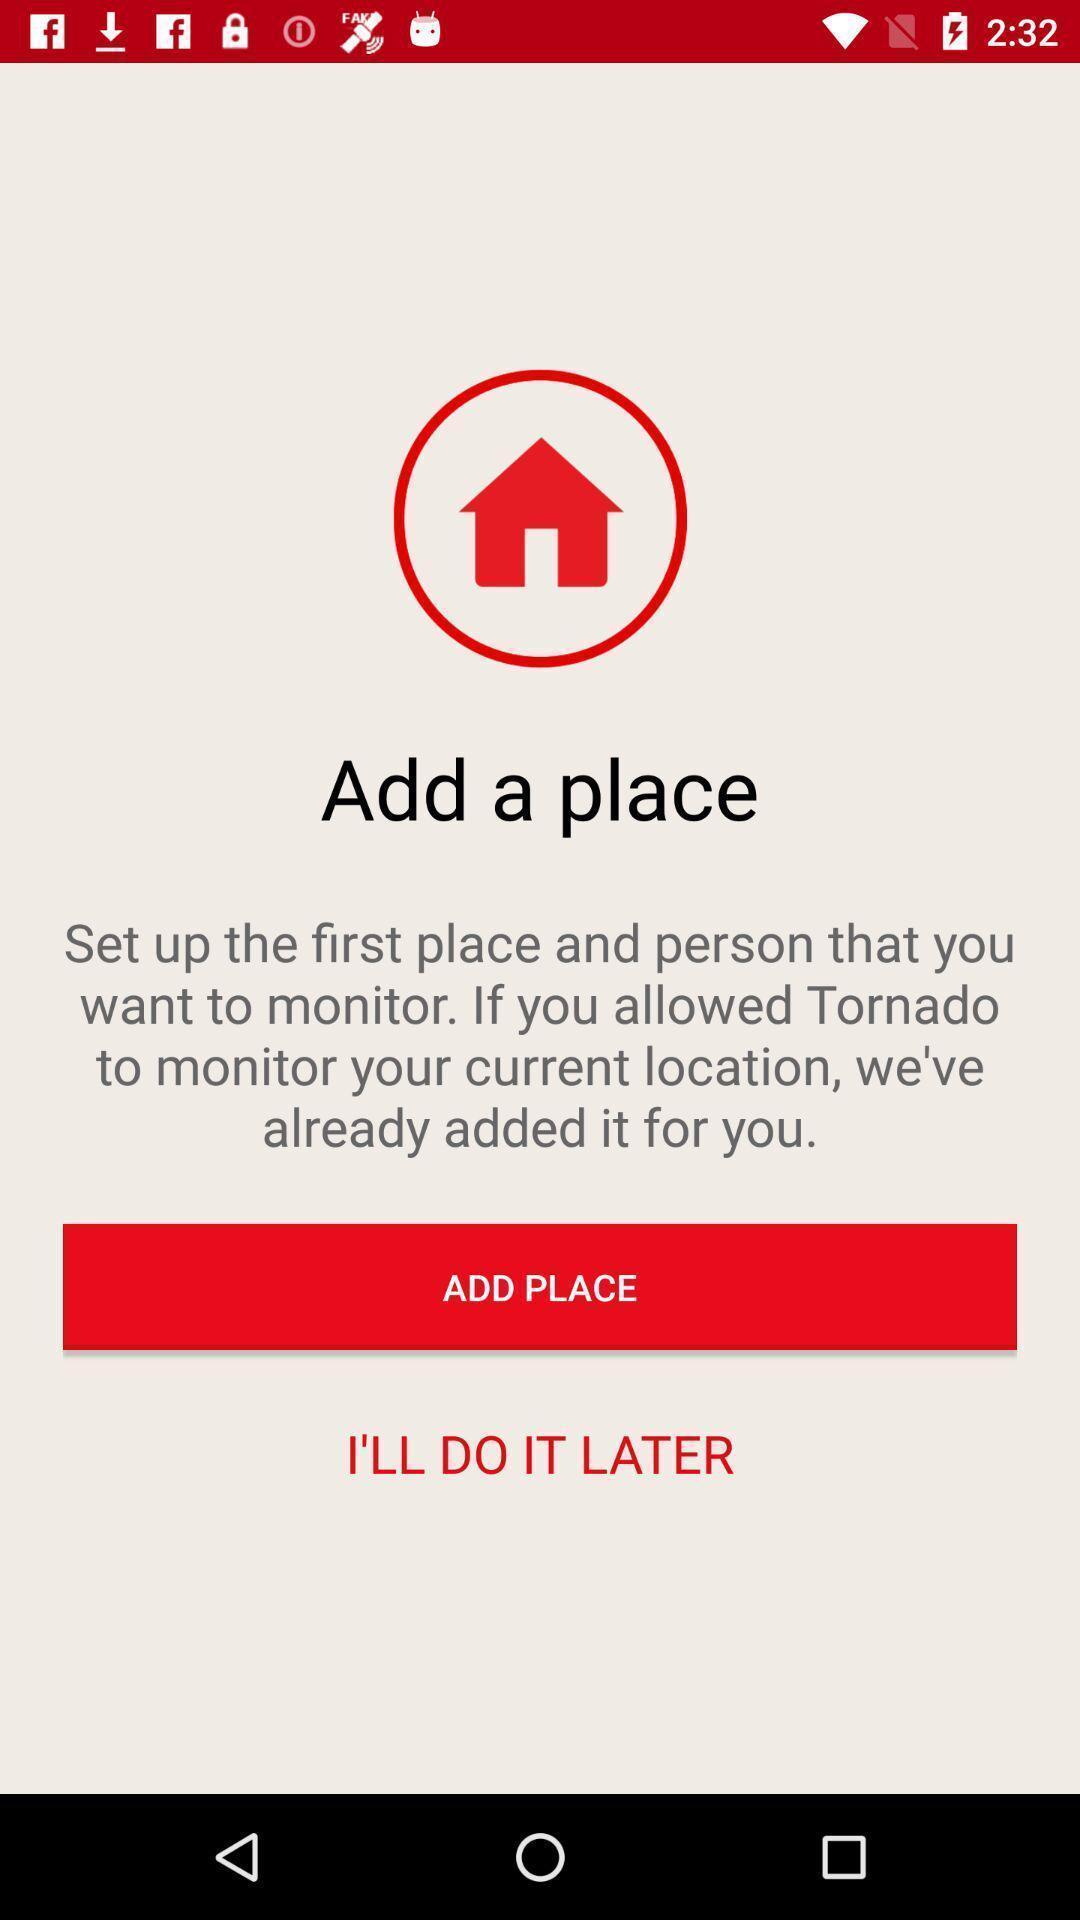Please provide a description for this image. Screen asking to add a place to monitor. 